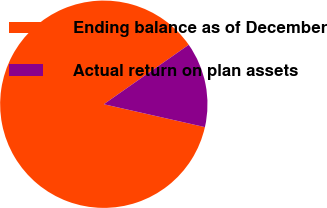Convert chart. <chart><loc_0><loc_0><loc_500><loc_500><pie_chart><fcel>Ending balance as of December<fcel>Actual return on plan assets<nl><fcel>86.74%<fcel>13.26%<nl></chart> 